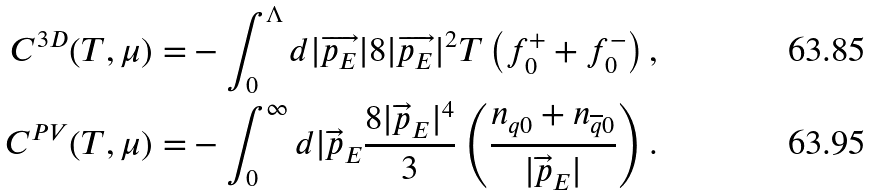Convert formula to latex. <formula><loc_0><loc_0><loc_500><loc_500>C ^ { 3 D } ( T , \mu ) = & - \int ^ { \Lambda } _ { 0 } d | \overrightarrow { p _ { E } } | 8 | \overrightarrow { p _ { E } } | ^ { 2 } T \left ( f ^ { + } _ { 0 } + f ^ { - } _ { 0 } \right ) , \\ C ^ { P V } ( T , \mu ) = & - \int ^ { \infty } _ { 0 } d | \overrightarrow { p } _ { E } \frac { 8 | \overrightarrow { p } _ { E } | ^ { 4 } } { 3 } \left ( \frac { n _ { q 0 } + n _ { \overline { q } 0 } } { | \overrightarrow { p } _ { E } | } \right ) .</formula> 